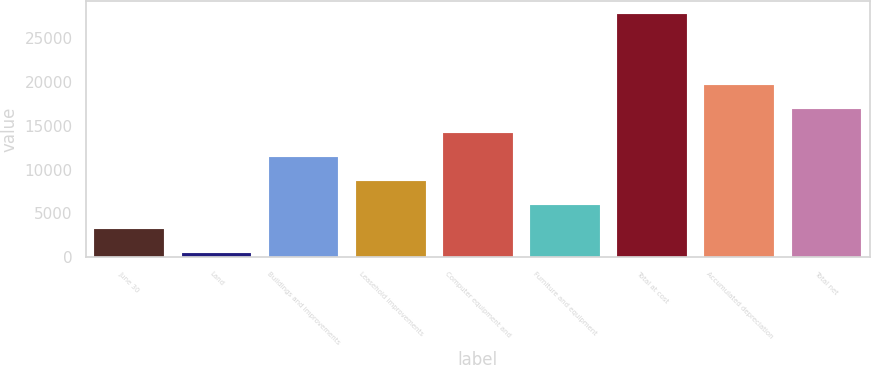Convert chart. <chart><loc_0><loc_0><loc_500><loc_500><bar_chart><fcel>June 30<fcel>Land<fcel>Buildings and improvements<fcel>Leasehold improvements<fcel>Computer equipment and<fcel>Furniture and equipment<fcel>Total at cost<fcel>Accumulated depreciation<fcel>Total net<nl><fcel>3267.3<fcel>541<fcel>11446.2<fcel>8719.9<fcel>14172.5<fcel>5993.6<fcel>27804<fcel>19625.1<fcel>16898.8<nl></chart> 